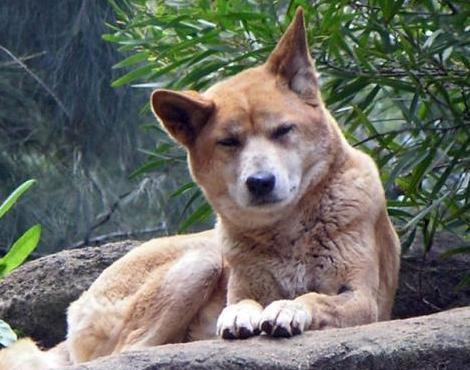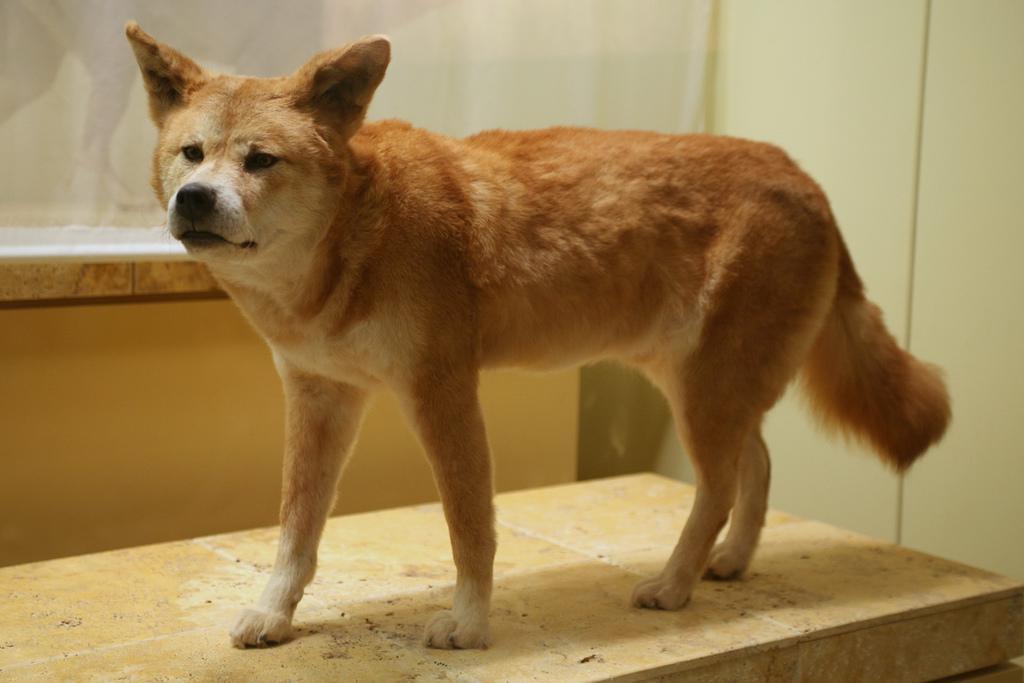The first image is the image on the left, the second image is the image on the right. Considering the images on both sides, is "The dog on the left is sleepy-looking." valid? Answer yes or no. Yes. 